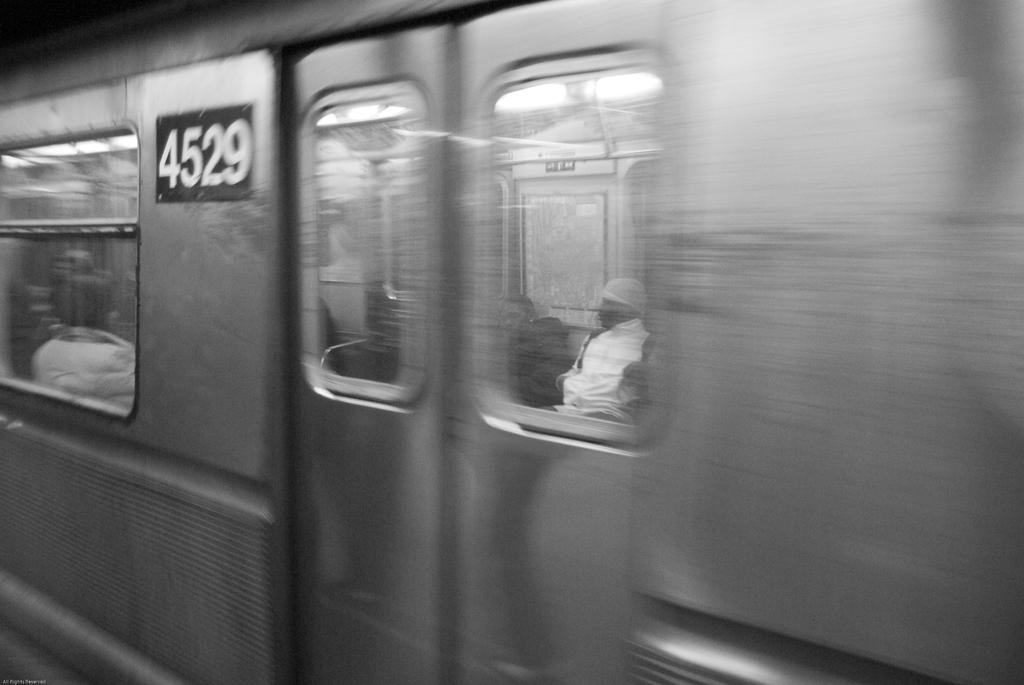What is the main subject of the picture? The main subject of the picture is a train. Are there any specific features of the train mentioned in the facts? No, the facts do not mention any specific features of the train. What else can be seen in the picture besides the train? There is a door, a window, a board, and people in the picture. How does the patch of grass in the image help the people during the rainstorm? There is no patch of grass mentioned in the image, nor is there any mention of a rainstorm. 